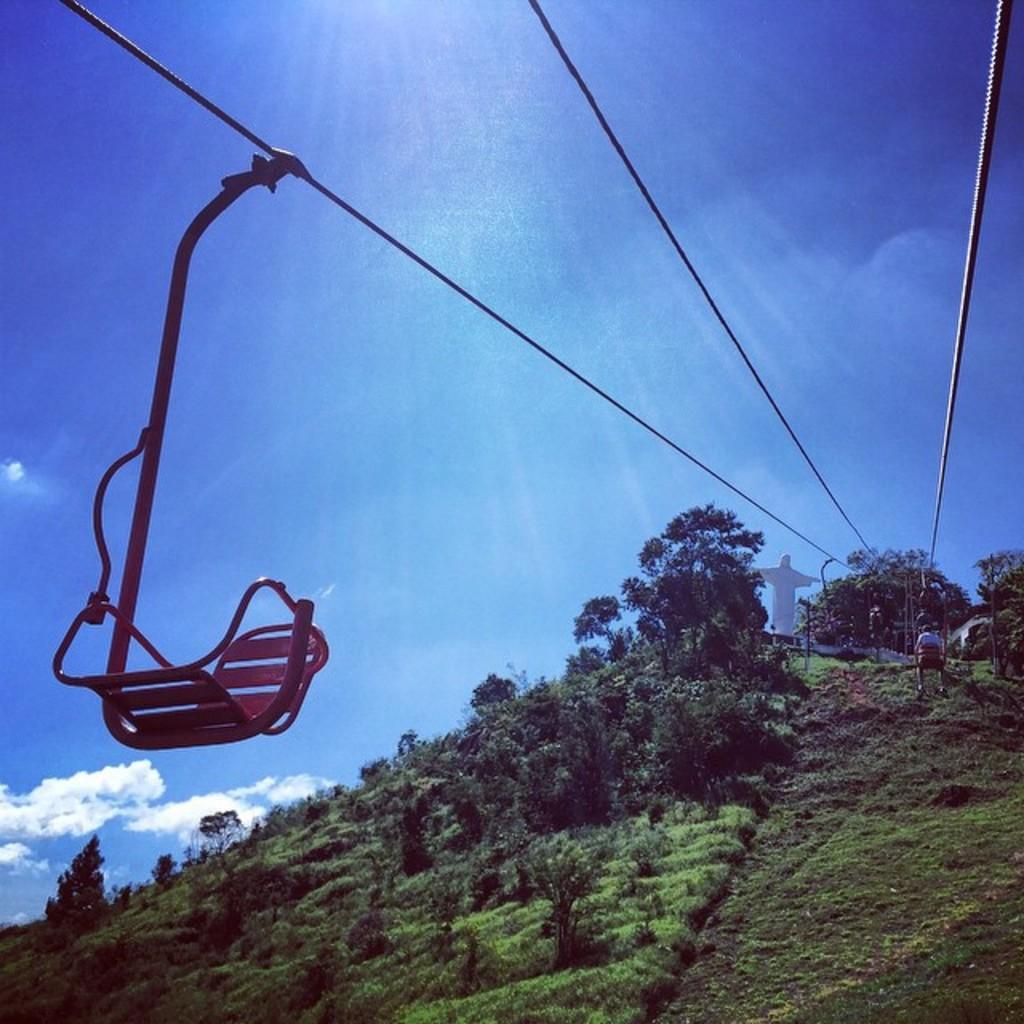Can you describe this image briefly? In this image we can see hill, trees, grass, ropeway, persons, statue and sky with clouds. 